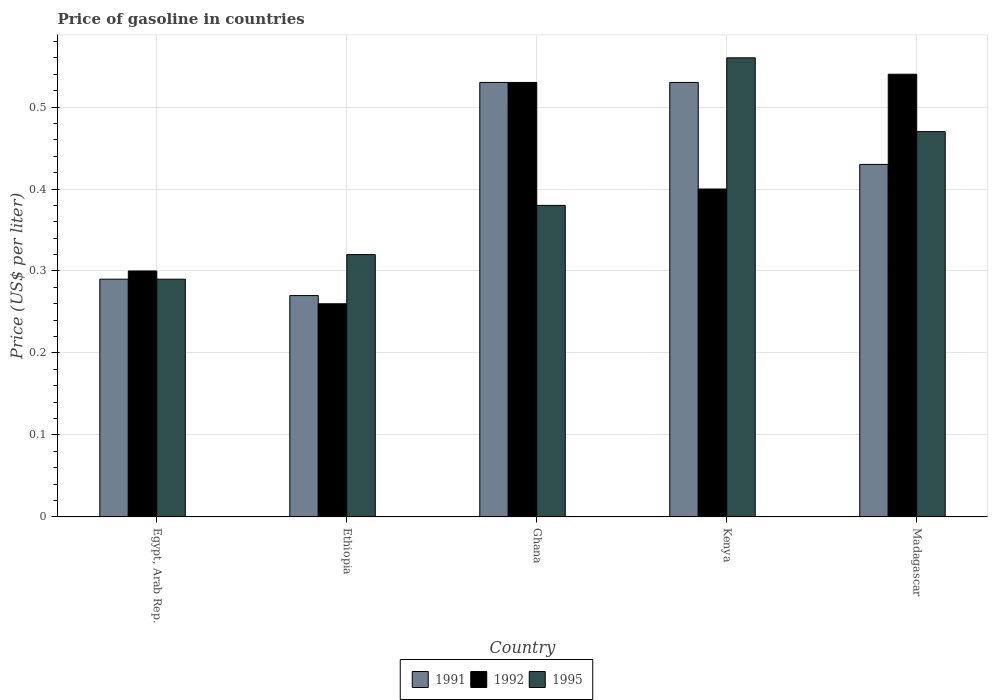How many different coloured bars are there?
Make the answer very short. 3. Are the number of bars on each tick of the X-axis equal?
Your answer should be very brief. Yes. How many bars are there on the 5th tick from the left?
Your answer should be compact. 3. How many bars are there on the 5th tick from the right?
Offer a very short reply. 3. What is the label of the 5th group of bars from the left?
Offer a terse response. Madagascar. In how many cases, is the number of bars for a given country not equal to the number of legend labels?
Provide a short and direct response. 0. What is the price of gasoline in 1992 in Egypt, Arab Rep.?
Give a very brief answer. 0.3. Across all countries, what is the maximum price of gasoline in 1995?
Give a very brief answer. 0.56. Across all countries, what is the minimum price of gasoline in 1992?
Give a very brief answer. 0.26. In which country was the price of gasoline in 1995 maximum?
Offer a terse response. Kenya. In which country was the price of gasoline in 1991 minimum?
Your answer should be compact. Ethiopia. What is the total price of gasoline in 1992 in the graph?
Your answer should be compact. 2.03. What is the difference between the price of gasoline in 1991 in Kenya and that in Madagascar?
Ensure brevity in your answer.  0.1. What is the difference between the price of gasoline in 1991 in Ghana and the price of gasoline in 1992 in Ethiopia?
Your response must be concise. 0.27. What is the average price of gasoline in 1992 per country?
Make the answer very short. 0.41. What is the difference between the price of gasoline of/in 1995 and price of gasoline of/in 1991 in Kenya?
Offer a very short reply. 0.03. What is the ratio of the price of gasoline in 1991 in Egypt, Arab Rep. to that in Ghana?
Your answer should be compact. 0.55. Is the difference between the price of gasoline in 1995 in Egypt, Arab Rep. and Madagascar greater than the difference between the price of gasoline in 1991 in Egypt, Arab Rep. and Madagascar?
Give a very brief answer. No. What is the difference between the highest and the second highest price of gasoline in 1992?
Offer a terse response. 0.01. What is the difference between the highest and the lowest price of gasoline in 1992?
Offer a terse response. 0.28. In how many countries, is the price of gasoline in 1991 greater than the average price of gasoline in 1991 taken over all countries?
Your answer should be compact. 3. What does the 3rd bar from the left in Ghana represents?
Offer a terse response. 1995. How many countries are there in the graph?
Offer a very short reply. 5. Are the values on the major ticks of Y-axis written in scientific E-notation?
Ensure brevity in your answer.  No. What is the title of the graph?
Provide a short and direct response. Price of gasoline in countries. Does "2002" appear as one of the legend labels in the graph?
Your answer should be compact. No. What is the label or title of the X-axis?
Your answer should be compact. Country. What is the label or title of the Y-axis?
Provide a short and direct response. Price (US$ per liter). What is the Price (US$ per liter) in 1991 in Egypt, Arab Rep.?
Ensure brevity in your answer.  0.29. What is the Price (US$ per liter) in 1995 in Egypt, Arab Rep.?
Make the answer very short. 0.29. What is the Price (US$ per liter) of 1991 in Ethiopia?
Offer a terse response. 0.27. What is the Price (US$ per liter) of 1992 in Ethiopia?
Give a very brief answer. 0.26. What is the Price (US$ per liter) in 1995 in Ethiopia?
Provide a succinct answer. 0.32. What is the Price (US$ per liter) of 1991 in Ghana?
Offer a very short reply. 0.53. What is the Price (US$ per liter) of 1992 in Ghana?
Provide a short and direct response. 0.53. What is the Price (US$ per liter) in 1995 in Ghana?
Your response must be concise. 0.38. What is the Price (US$ per liter) in 1991 in Kenya?
Offer a very short reply. 0.53. What is the Price (US$ per liter) of 1995 in Kenya?
Your answer should be very brief. 0.56. What is the Price (US$ per liter) in 1991 in Madagascar?
Ensure brevity in your answer.  0.43. What is the Price (US$ per liter) in 1992 in Madagascar?
Your answer should be compact. 0.54. What is the Price (US$ per liter) of 1995 in Madagascar?
Give a very brief answer. 0.47. Across all countries, what is the maximum Price (US$ per liter) in 1991?
Offer a very short reply. 0.53. Across all countries, what is the maximum Price (US$ per liter) in 1992?
Keep it short and to the point. 0.54. Across all countries, what is the maximum Price (US$ per liter) in 1995?
Your answer should be very brief. 0.56. Across all countries, what is the minimum Price (US$ per liter) of 1991?
Ensure brevity in your answer.  0.27. Across all countries, what is the minimum Price (US$ per liter) of 1992?
Offer a terse response. 0.26. Across all countries, what is the minimum Price (US$ per liter) of 1995?
Make the answer very short. 0.29. What is the total Price (US$ per liter) in 1991 in the graph?
Ensure brevity in your answer.  2.05. What is the total Price (US$ per liter) in 1992 in the graph?
Provide a short and direct response. 2.03. What is the total Price (US$ per liter) of 1995 in the graph?
Provide a short and direct response. 2.02. What is the difference between the Price (US$ per liter) of 1992 in Egypt, Arab Rep. and that in Ethiopia?
Give a very brief answer. 0.04. What is the difference between the Price (US$ per liter) in 1995 in Egypt, Arab Rep. and that in Ethiopia?
Provide a succinct answer. -0.03. What is the difference between the Price (US$ per liter) of 1991 in Egypt, Arab Rep. and that in Ghana?
Offer a very short reply. -0.24. What is the difference between the Price (US$ per liter) of 1992 in Egypt, Arab Rep. and that in Ghana?
Keep it short and to the point. -0.23. What is the difference between the Price (US$ per liter) in 1995 in Egypt, Arab Rep. and that in Ghana?
Offer a very short reply. -0.09. What is the difference between the Price (US$ per liter) in 1991 in Egypt, Arab Rep. and that in Kenya?
Keep it short and to the point. -0.24. What is the difference between the Price (US$ per liter) in 1992 in Egypt, Arab Rep. and that in Kenya?
Keep it short and to the point. -0.1. What is the difference between the Price (US$ per liter) of 1995 in Egypt, Arab Rep. and that in Kenya?
Give a very brief answer. -0.27. What is the difference between the Price (US$ per liter) of 1991 in Egypt, Arab Rep. and that in Madagascar?
Keep it short and to the point. -0.14. What is the difference between the Price (US$ per liter) of 1992 in Egypt, Arab Rep. and that in Madagascar?
Keep it short and to the point. -0.24. What is the difference between the Price (US$ per liter) in 1995 in Egypt, Arab Rep. and that in Madagascar?
Your response must be concise. -0.18. What is the difference between the Price (US$ per liter) of 1991 in Ethiopia and that in Ghana?
Provide a short and direct response. -0.26. What is the difference between the Price (US$ per liter) of 1992 in Ethiopia and that in Ghana?
Make the answer very short. -0.27. What is the difference between the Price (US$ per liter) of 1995 in Ethiopia and that in Ghana?
Keep it short and to the point. -0.06. What is the difference between the Price (US$ per liter) of 1991 in Ethiopia and that in Kenya?
Give a very brief answer. -0.26. What is the difference between the Price (US$ per liter) in 1992 in Ethiopia and that in Kenya?
Provide a succinct answer. -0.14. What is the difference between the Price (US$ per liter) in 1995 in Ethiopia and that in Kenya?
Provide a short and direct response. -0.24. What is the difference between the Price (US$ per liter) of 1991 in Ethiopia and that in Madagascar?
Your response must be concise. -0.16. What is the difference between the Price (US$ per liter) of 1992 in Ethiopia and that in Madagascar?
Give a very brief answer. -0.28. What is the difference between the Price (US$ per liter) of 1995 in Ethiopia and that in Madagascar?
Ensure brevity in your answer.  -0.15. What is the difference between the Price (US$ per liter) of 1991 in Ghana and that in Kenya?
Your answer should be compact. 0. What is the difference between the Price (US$ per liter) in 1992 in Ghana and that in Kenya?
Your answer should be compact. 0.13. What is the difference between the Price (US$ per liter) in 1995 in Ghana and that in Kenya?
Provide a short and direct response. -0.18. What is the difference between the Price (US$ per liter) of 1992 in Ghana and that in Madagascar?
Give a very brief answer. -0.01. What is the difference between the Price (US$ per liter) in 1995 in Ghana and that in Madagascar?
Your answer should be very brief. -0.09. What is the difference between the Price (US$ per liter) in 1991 in Kenya and that in Madagascar?
Keep it short and to the point. 0.1. What is the difference between the Price (US$ per liter) of 1992 in Kenya and that in Madagascar?
Offer a very short reply. -0.14. What is the difference between the Price (US$ per liter) of 1995 in Kenya and that in Madagascar?
Provide a short and direct response. 0.09. What is the difference between the Price (US$ per liter) of 1991 in Egypt, Arab Rep. and the Price (US$ per liter) of 1992 in Ethiopia?
Offer a terse response. 0.03. What is the difference between the Price (US$ per liter) of 1991 in Egypt, Arab Rep. and the Price (US$ per liter) of 1995 in Ethiopia?
Give a very brief answer. -0.03. What is the difference between the Price (US$ per liter) in 1992 in Egypt, Arab Rep. and the Price (US$ per liter) in 1995 in Ethiopia?
Offer a terse response. -0.02. What is the difference between the Price (US$ per liter) of 1991 in Egypt, Arab Rep. and the Price (US$ per liter) of 1992 in Ghana?
Provide a short and direct response. -0.24. What is the difference between the Price (US$ per liter) in 1991 in Egypt, Arab Rep. and the Price (US$ per liter) in 1995 in Ghana?
Provide a short and direct response. -0.09. What is the difference between the Price (US$ per liter) in 1992 in Egypt, Arab Rep. and the Price (US$ per liter) in 1995 in Ghana?
Make the answer very short. -0.08. What is the difference between the Price (US$ per liter) in 1991 in Egypt, Arab Rep. and the Price (US$ per liter) in 1992 in Kenya?
Provide a short and direct response. -0.11. What is the difference between the Price (US$ per liter) of 1991 in Egypt, Arab Rep. and the Price (US$ per liter) of 1995 in Kenya?
Make the answer very short. -0.27. What is the difference between the Price (US$ per liter) in 1992 in Egypt, Arab Rep. and the Price (US$ per liter) in 1995 in Kenya?
Offer a terse response. -0.26. What is the difference between the Price (US$ per liter) in 1991 in Egypt, Arab Rep. and the Price (US$ per liter) in 1995 in Madagascar?
Give a very brief answer. -0.18. What is the difference between the Price (US$ per liter) of 1992 in Egypt, Arab Rep. and the Price (US$ per liter) of 1995 in Madagascar?
Ensure brevity in your answer.  -0.17. What is the difference between the Price (US$ per liter) of 1991 in Ethiopia and the Price (US$ per liter) of 1992 in Ghana?
Offer a very short reply. -0.26. What is the difference between the Price (US$ per liter) in 1991 in Ethiopia and the Price (US$ per liter) in 1995 in Ghana?
Provide a short and direct response. -0.11. What is the difference between the Price (US$ per liter) of 1992 in Ethiopia and the Price (US$ per liter) of 1995 in Ghana?
Give a very brief answer. -0.12. What is the difference between the Price (US$ per liter) of 1991 in Ethiopia and the Price (US$ per liter) of 1992 in Kenya?
Ensure brevity in your answer.  -0.13. What is the difference between the Price (US$ per liter) of 1991 in Ethiopia and the Price (US$ per liter) of 1995 in Kenya?
Your answer should be compact. -0.29. What is the difference between the Price (US$ per liter) in 1992 in Ethiopia and the Price (US$ per liter) in 1995 in Kenya?
Provide a short and direct response. -0.3. What is the difference between the Price (US$ per liter) of 1991 in Ethiopia and the Price (US$ per liter) of 1992 in Madagascar?
Your answer should be compact. -0.27. What is the difference between the Price (US$ per liter) of 1991 in Ethiopia and the Price (US$ per liter) of 1995 in Madagascar?
Offer a terse response. -0.2. What is the difference between the Price (US$ per liter) in 1992 in Ethiopia and the Price (US$ per liter) in 1995 in Madagascar?
Make the answer very short. -0.21. What is the difference between the Price (US$ per liter) of 1991 in Ghana and the Price (US$ per liter) of 1992 in Kenya?
Provide a short and direct response. 0.13. What is the difference between the Price (US$ per liter) in 1991 in Ghana and the Price (US$ per liter) in 1995 in Kenya?
Ensure brevity in your answer.  -0.03. What is the difference between the Price (US$ per liter) in 1992 in Ghana and the Price (US$ per liter) in 1995 in Kenya?
Keep it short and to the point. -0.03. What is the difference between the Price (US$ per liter) in 1991 in Ghana and the Price (US$ per liter) in 1992 in Madagascar?
Give a very brief answer. -0.01. What is the difference between the Price (US$ per liter) of 1991 in Ghana and the Price (US$ per liter) of 1995 in Madagascar?
Your answer should be very brief. 0.06. What is the difference between the Price (US$ per liter) in 1991 in Kenya and the Price (US$ per liter) in 1992 in Madagascar?
Offer a very short reply. -0.01. What is the difference between the Price (US$ per liter) in 1991 in Kenya and the Price (US$ per liter) in 1995 in Madagascar?
Your answer should be compact. 0.06. What is the difference between the Price (US$ per liter) of 1992 in Kenya and the Price (US$ per liter) of 1995 in Madagascar?
Offer a terse response. -0.07. What is the average Price (US$ per liter) of 1991 per country?
Offer a very short reply. 0.41. What is the average Price (US$ per liter) of 1992 per country?
Provide a succinct answer. 0.41. What is the average Price (US$ per liter) in 1995 per country?
Your response must be concise. 0.4. What is the difference between the Price (US$ per liter) of 1991 and Price (US$ per liter) of 1992 in Egypt, Arab Rep.?
Make the answer very short. -0.01. What is the difference between the Price (US$ per liter) in 1991 and Price (US$ per liter) in 1995 in Egypt, Arab Rep.?
Make the answer very short. 0. What is the difference between the Price (US$ per liter) in 1992 and Price (US$ per liter) in 1995 in Egypt, Arab Rep.?
Your response must be concise. 0.01. What is the difference between the Price (US$ per liter) of 1991 and Price (US$ per liter) of 1992 in Ethiopia?
Your answer should be compact. 0.01. What is the difference between the Price (US$ per liter) in 1992 and Price (US$ per liter) in 1995 in Ethiopia?
Provide a succinct answer. -0.06. What is the difference between the Price (US$ per liter) of 1992 and Price (US$ per liter) of 1995 in Ghana?
Your answer should be very brief. 0.15. What is the difference between the Price (US$ per liter) of 1991 and Price (US$ per liter) of 1992 in Kenya?
Keep it short and to the point. 0.13. What is the difference between the Price (US$ per liter) of 1991 and Price (US$ per liter) of 1995 in Kenya?
Make the answer very short. -0.03. What is the difference between the Price (US$ per liter) of 1992 and Price (US$ per liter) of 1995 in Kenya?
Give a very brief answer. -0.16. What is the difference between the Price (US$ per liter) in 1991 and Price (US$ per liter) in 1992 in Madagascar?
Your answer should be compact. -0.11. What is the difference between the Price (US$ per liter) in 1991 and Price (US$ per liter) in 1995 in Madagascar?
Your response must be concise. -0.04. What is the difference between the Price (US$ per liter) of 1992 and Price (US$ per liter) of 1995 in Madagascar?
Keep it short and to the point. 0.07. What is the ratio of the Price (US$ per liter) in 1991 in Egypt, Arab Rep. to that in Ethiopia?
Make the answer very short. 1.07. What is the ratio of the Price (US$ per liter) of 1992 in Egypt, Arab Rep. to that in Ethiopia?
Give a very brief answer. 1.15. What is the ratio of the Price (US$ per liter) in 1995 in Egypt, Arab Rep. to that in Ethiopia?
Offer a very short reply. 0.91. What is the ratio of the Price (US$ per liter) in 1991 in Egypt, Arab Rep. to that in Ghana?
Offer a terse response. 0.55. What is the ratio of the Price (US$ per liter) in 1992 in Egypt, Arab Rep. to that in Ghana?
Make the answer very short. 0.57. What is the ratio of the Price (US$ per liter) in 1995 in Egypt, Arab Rep. to that in Ghana?
Ensure brevity in your answer.  0.76. What is the ratio of the Price (US$ per liter) of 1991 in Egypt, Arab Rep. to that in Kenya?
Offer a very short reply. 0.55. What is the ratio of the Price (US$ per liter) in 1995 in Egypt, Arab Rep. to that in Kenya?
Your response must be concise. 0.52. What is the ratio of the Price (US$ per liter) of 1991 in Egypt, Arab Rep. to that in Madagascar?
Make the answer very short. 0.67. What is the ratio of the Price (US$ per liter) of 1992 in Egypt, Arab Rep. to that in Madagascar?
Your answer should be compact. 0.56. What is the ratio of the Price (US$ per liter) of 1995 in Egypt, Arab Rep. to that in Madagascar?
Keep it short and to the point. 0.62. What is the ratio of the Price (US$ per liter) of 1991 in Ethiopia to that in Ghana?
Your answer should be very brief. 0.51. What is the ratio of the Price (US$ per liter) in 1992 in Ethiopia to that in Ghana?
Offer a terse response. 0.49. What is the ratio of the Price (US$ per liter) of 1995 in Ethiopia to that in Ghana?
Give a very brief answer. 0.84. What is the ratio of the Price (US$ per liter) of 1991 in Ethiopia to that in Kenya?
Make the answer very short. 0.51. What is the ratio of the Price (US$ per liter) of 1992 in Ethiopia to that in Kenya?
Offer a terse response. 0.65. What is the ratio of the Price (US$ per liter) in 1991 in Ethiopia to that in Madagascar?
Your answer should be very brief. 0.63. What is the ratio of the Price (US$ per liter) of 1992 in Ethiopia to that in Madagascar?
Keep it short and to the point. 0.48. What is the ratio of the Price (US$ per liter) in 1995 in Ethiopia to that in Madagascar?
Your answer should be very brief. 0.68. What is the ratio of the Price (US$ per liter) in 1991 in Ghana to that in Kenya?
Give a very brief answer. 1. What is the ratio of the Price (US$ per liter) in 1992 in Ghana to that in Kenya?
Provide a short and direct response. 1.32. What is the ratio of the Price (US$ per liter) in 1995 in Ghana to that in Kenya?
Provide a short and direct response. 0.68. What is the ratio of the Price (US$ per liter) in 1991 in Ghana to that in Madagascar?
Ensure brevity in your answer.  1.23. What is the ratio of the Price (US$ per liter) of 1992 in Ghana to that in Madagascar?
Ensure brevity in your answer.  0.98. What is the ratio of the Price (US$ per liter) in 1995 in Ghana to that in Madagascar?
Give a very brief answer. 0.81. What is the ratio of the Price (US$ per liter) of 1991 in Kenya to that in Madagascar?
Provide a succinct answer. 1.23. What is the ratio of the Price (US$ per liter) of 1992 in Kenya to that in Madagascar?
Provide a succinct answer. 0.74. What is the ratio of the Price (US$ per liter) of 1995 in Kenya to that in Madagascar?
Make the answer very short. 1.19. What is the difference between the highest and the second highest Price (US$ per liter) of 1995?
Offer a terse response. 0.09. What is the difference between the highest and the lowest Price (US$ per liter) in 1991?
Provide a succinct answer. 0.26. What is the difference between the highest and the lowest Price (US$ per liter) of 1992?
Your response must be concise. 0.28. What is the difference between the highest and the lowest Price (US$ per liter) of 1995?
Your answer should be very brief. 0.27. 